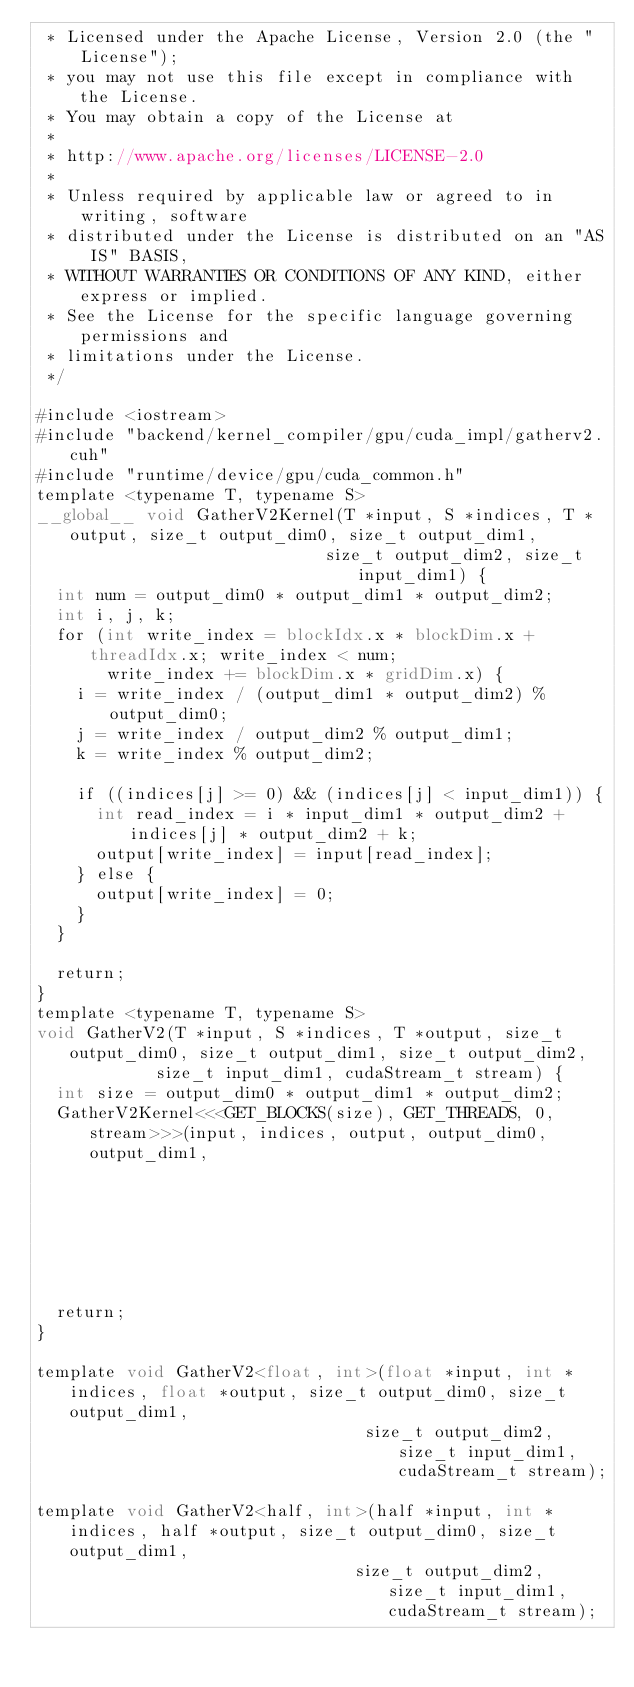<code> <loc_0><loc_0><loc_500><loc_500><_Cuda_> * Licensed under the Apache License, Version 2.0 (the "License");
 * you may not use this file except in compliance with the License.
 * You may obtain a copy of the License at
 *
 * http://www.apache.org/licenses/LICENSE-2.0
 *
 * Unless required by applicable law or agreed to in writing, software
 * distributed under the License is distributed on an "AS IS" BASIS,
 * WITHOUT WARRANTIES OR CONDITIONS OF ANY KIND, either express or implied.
 * See the License for the specific language governing permissions and
 * limitations under the License.
 */

#include <iostream>
#include "backend/kernel_compiler/gpu/cuda_impl/gatherv2.cuh"
#include "runtime/device/gpu/cuda_common.h"
template <typename T, typename S>
__global__ void GatherV2Kernel(T *input, S *indices, T *output, size_t output_dim0, size_t output_dim1,
                             size_t output_dim2, size_t input_dim1) {
  int num = output_dim0 * output_dim1 * output_dim2;
  int i, j, k;
  for (int write_index = blockIdx.x * blockDim.x + threadIdx.x; write_index < num;
       write_index += blockDim.x * gridDim.x) {
    i = write_index / (output_dim1 * output_dim2) % output_dim0;
    j = write_index / output_dim2 % output_dim1;
    k = write_index % output_dim2;

    if ((indices[j] >= 0) && (indices[j] < input_dim1)) {
      int read_index = i * input_dim1 * output_dim2 + indices[j] * output_dim2 + k;
      output[write_index] = input[read_index];
    } else {
      output[write_index] = 0;
    }
  }

  return;
}
template <typename T, typename S>
void GatherV2(T *input, S *indices, T *output, size_t output_dim0, size_t output_dim1, size_t output_dim2,
            size_t input_dim1, cudaStream_t stream) {
  int size = output_dim0 * output_dim1 * output_dim2;
  GatherV2Kernel<<<GET_BLOCKS(size), GET_THREADS, 0, stream>>>(input, indices, output, output_dim0, output_dim1,
                                                             output_dim2, input_dim1);
  return;
}

template void GatherV2<float, int>(float *input, int *indices, float *output, size_t output_dim0, size_t output_dim1,
                                 size_t output_dim2, size_t input_dim1, cudaStream_t stream);

template void GatherV2<half, int>(half *input, int *indices, half *output, size_t output_dim0, size_t output_dim1,
                                size_t output_dim2, size_t input_dim1, cudaStream_t stream);
</code> 